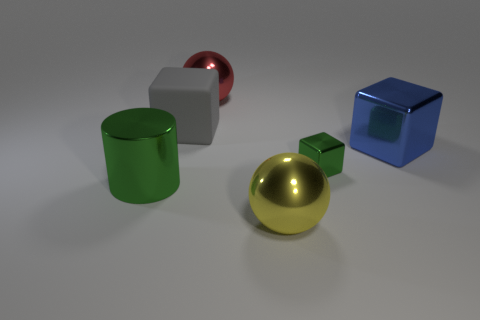Do the large cylinder and the small metal block have the same color?
Offer a terse response. Yes. What shape is the large metallic thing that is the same color as the tiny object?
Ensure brevity in your answer.  Cylinder. What shape is the shiny thing in front of the big shiny cylinder?
Ensure brevity in your answer.  Sphere. What shape is the tiny green shiny object that is right of the big metallic sphere that is in front of the gray matte thing?
Ensure brevity in your answer.  Cube. Is there another large gray rubber object that has the same shape as the large gray matte thing?
Offer a terse response. No. There is a blue thing that is the same size as the red shiny object; what shape is it?
Ensure brevity in your answer.  Cube. There is a shiny sphere behind the large cube on the right side of the small metal thing; are there any balls that are on the right side of it?
Offer a very short reply. Yes. Is there a red sphere that has the same size as the metal cylinder?
Ensure brevity in your answer.  Yes. What size is the rubber cube that is left of the yellow metallic sphere?
Give a very brief answer. Large. The shiny sphere behind the block on the left side of the big thing behind the gray rubber cube is what color?
Your answer should be compact. Red. 